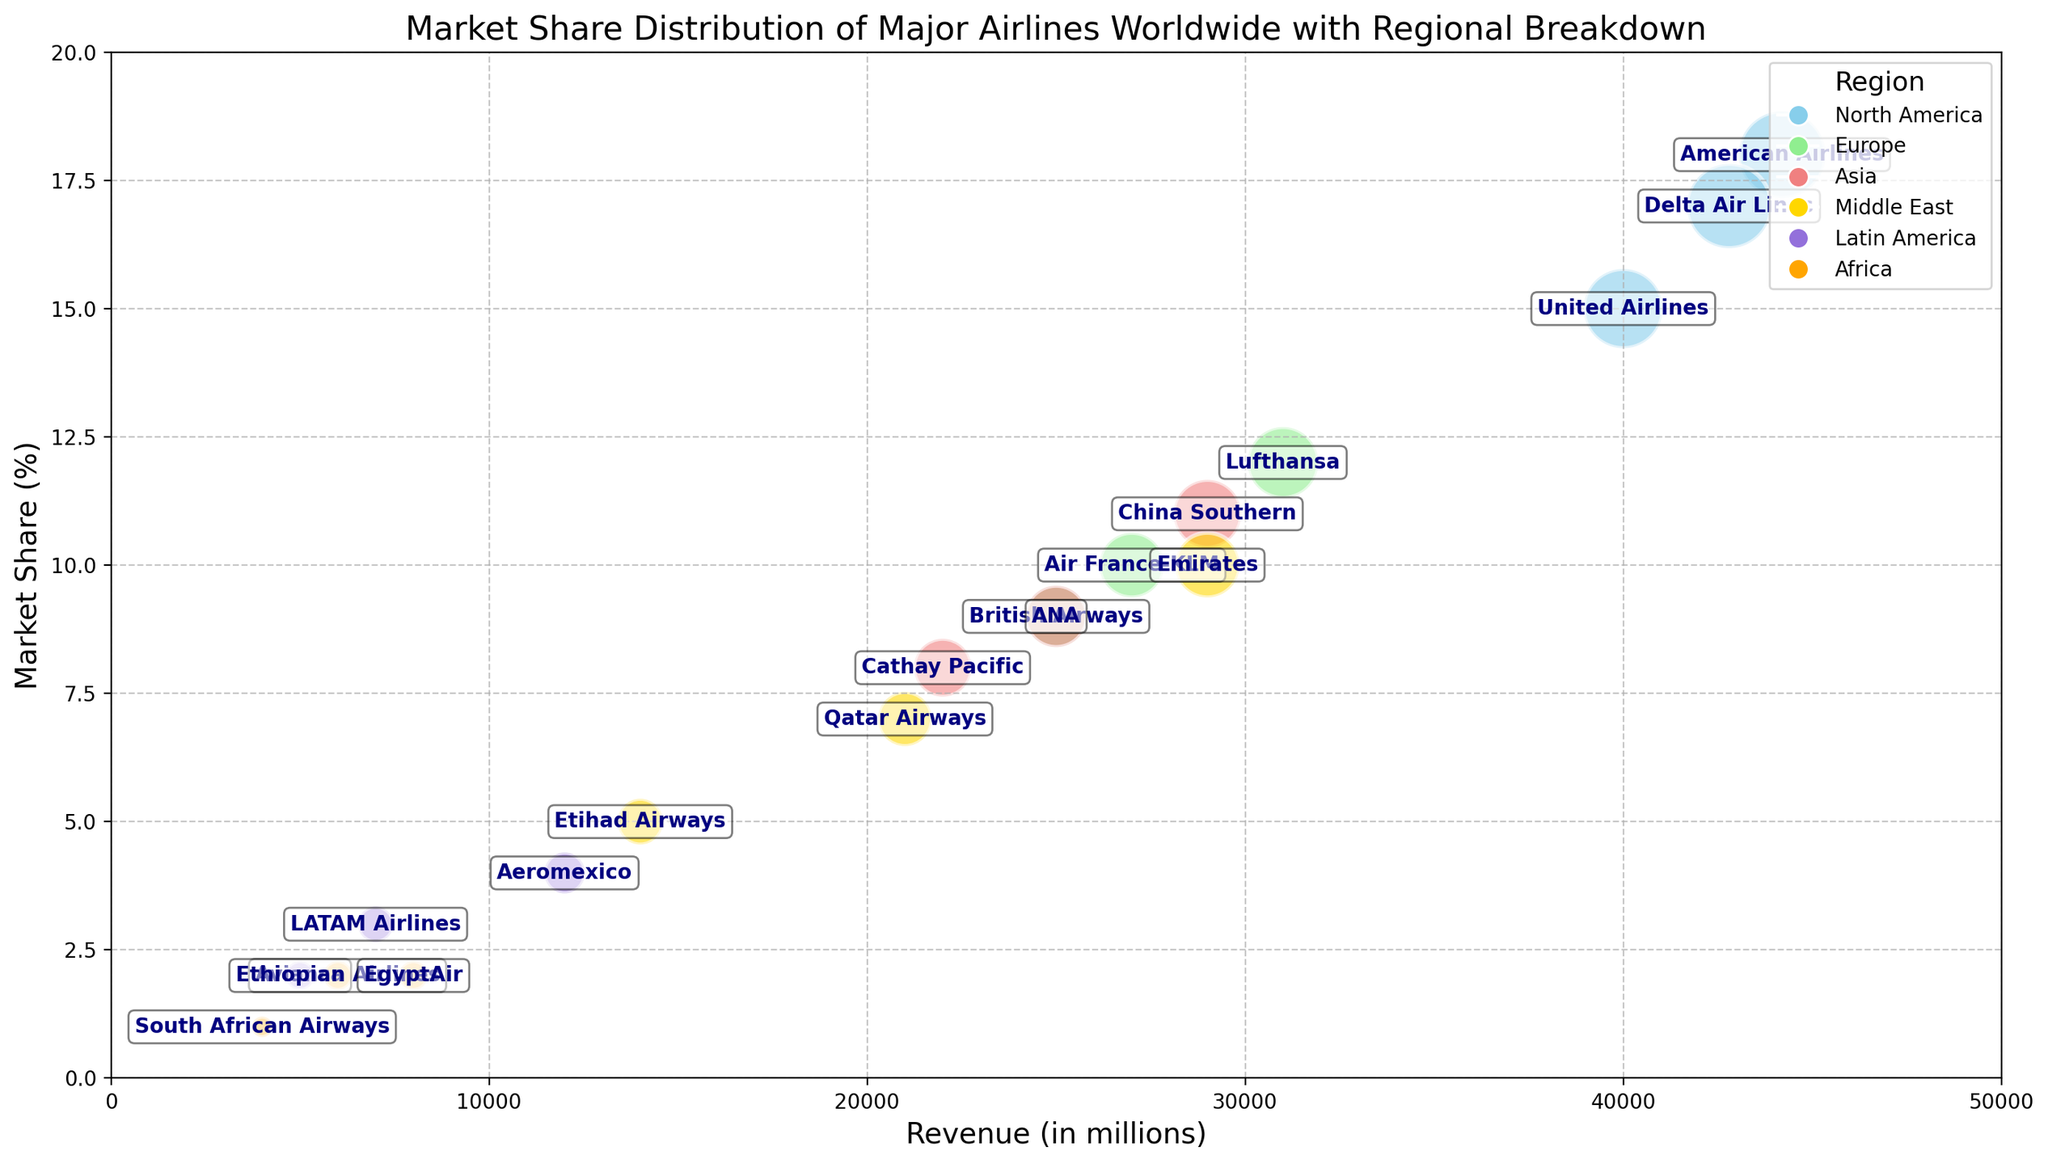Which airline has the highest market share? The airline with the highest market share is identified by the largest bubble size in the visual representation. From the figure, American Airlines has the largest bubble size at 18%.
Answer: American Airlines How does the revenue of Qatar Airways compare to that of Emirates? By observing the x-axis positions of the bubbles, Qatar Airways is positioned around 21,000 million, while Emirates is around 29,000 million.
Answer: Emirates has higher revenue Which region has the most airlines represented in the chart? Count the airlines represented by each color according to the legend. North America has three airlines (blue), while Europe also has three (green), and Asia has three (red). However, North America is listed first.
Answer: North America (or tied with Europe and Asia) What is the combined market share of Delta Air Lines and United Airlines? Refer to the market shares next to the bubbles for Delta Air Lines (17%) and United Airlines (15%). Sum these values to find the combined market share.
Answer: 32% Which airline in the Middle East has the smallest market share, and what is its value? Compare the market share percentages for Qatar Airways (7%), Emirates (10%), and Etihad Airways (5%). The smallest value is 5%.
Answer: Etihad Airways, 5% Do airlines with higher revenues tend to have higher market shares? Observe the relationship between x-axis (revenue) and bubble size (market share). Some high-revenue airlines have high market shares, but there are exceptions suggesting no strict trend.
Answer: Not necessarily Which airline has the closest market share to British Airways? Compare market shares and find 9% for British Airways. Look for other bubbles near 9%, leading to ANA (9%).
Answer: ANA How many airlines have a market share larger than 10%? Identify and count distinct bubbles larger than 10%. American Airlines (18%), Delta Air Lines (17%), United Airlines (15%), China Southern (11%), and Lufthansa (12%) meet the criterion. Five in total.
Answer: 5 airlines What is the total revenue generated by airlines in Latin America? Sum the revenues of the Latin American airlines: LATAM Airlines (7000), Avianca (5000), Aeromexico (12000). Adding these values gives 7000 + 5000 + 12000 = 24000 million.
Answer: 24000 million Which airline has a larger market share, Ethiopian Airlines or South African Airways? Compare market shares given next to their bubbles. Ethiopian Airlines has 2%, whereas South African Airways has 1%.
Answer: Ethiopian Airlines 